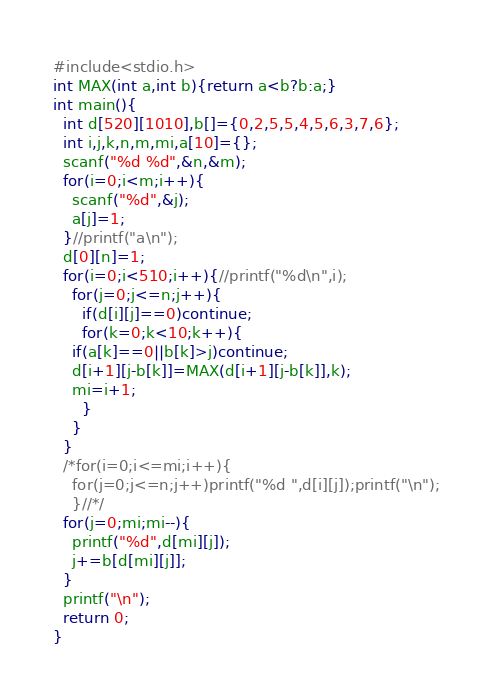Convert code to text. <code><loc_0><loc_0><loc_500><loc_500><_C_>#include<stdio.h>
int MAX(int a,int b){return a<b?b:a;}
int main(){
  int d[520][1010],b[]={0,2,5,5,4,5,6,3,7,6};
  int i,j,k,n,m,mi,a[10]={};
  scanf("%d %d",&n,&m);
  for(i=0;i<m;i++){
    scanf("%d",&j);
    a[j]=1;
  }//printf("a\n");
  d[0][n]=1;
  for(i=0;i<510;i++){//printf("%d\n",i);
    for(j=0;j<=n;j++){
      if(d[i][j]==0)continue;
      for(k=0;k<10;k++){
	if(a[k]==0||b[k]>j)continue;
	d[i+1][j-b[k]]=MAX(d[i+1][j-b[k]],k);
	mi=i+1;
      }
    }
  }
  /*for(i=0;i<=mi;i++){
    for(j=0;j<=n;j++)printf("%d ",d[i][j]);printf("\n");
    }//*/
  for(j=0;mi;mi--){
    printf("%d",d[mi][j]);
    j+=b[d[mi][j]];
  }
  printf("\n");
  return 0;
}
</code> 